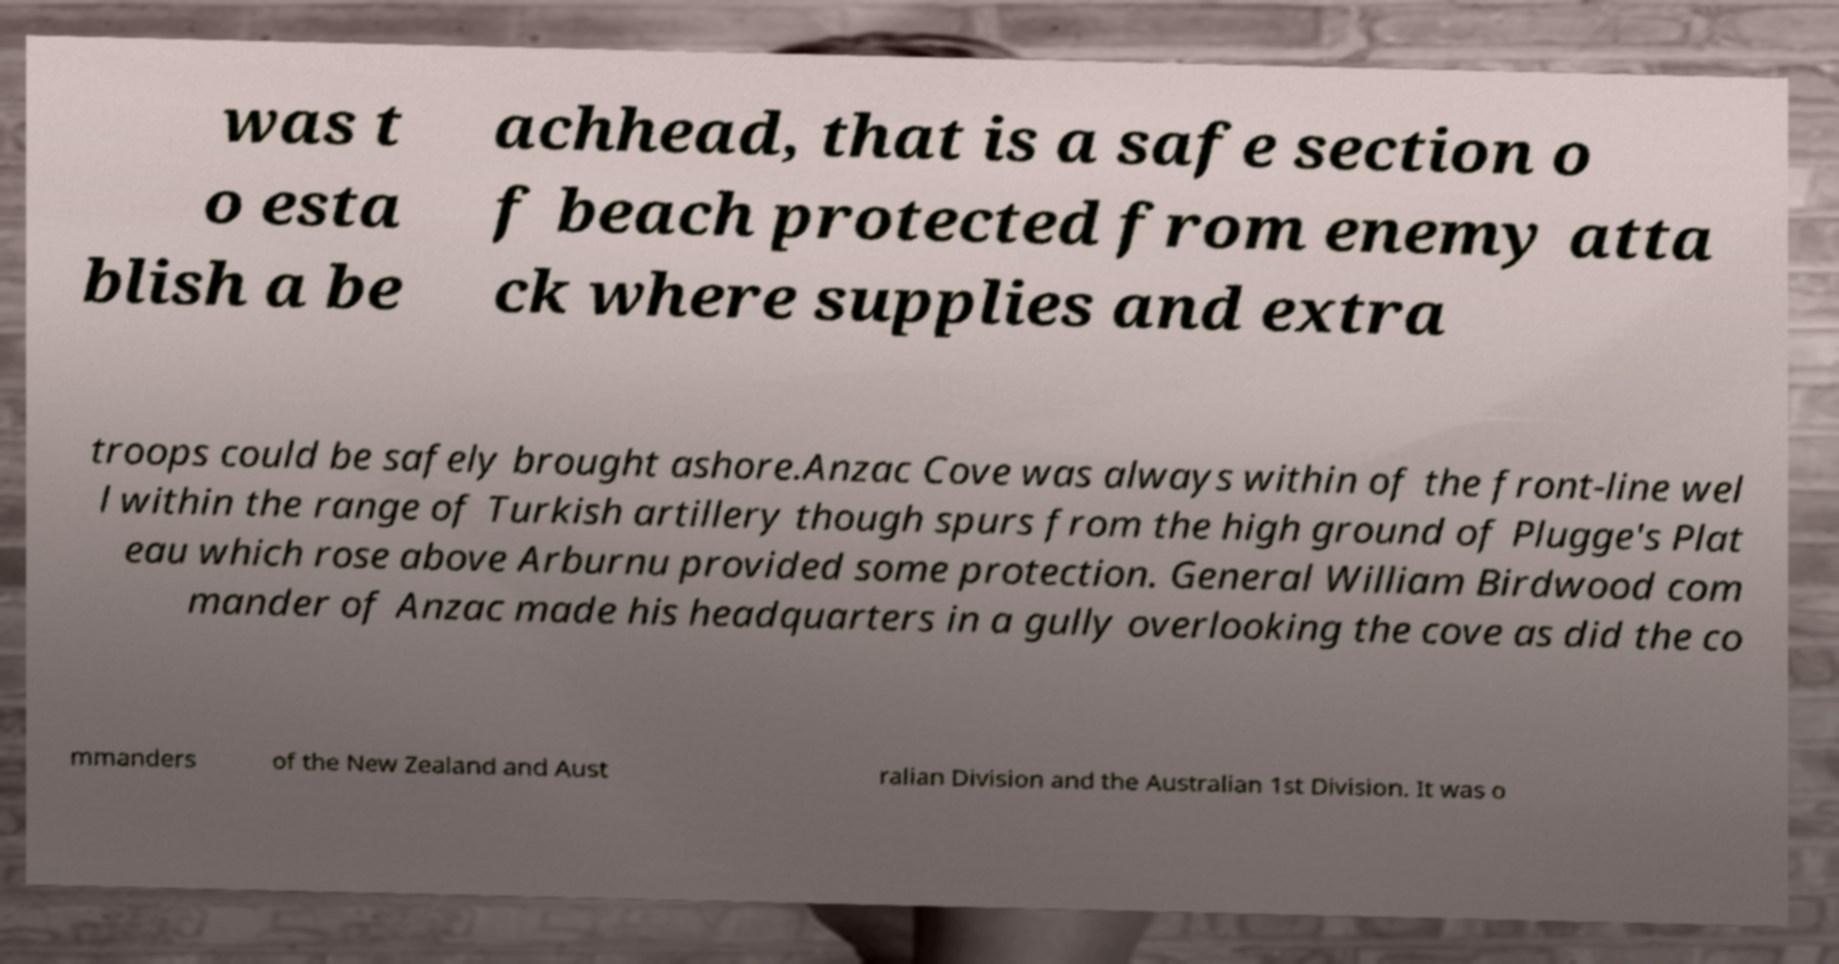Can you read and provide the text displayed in the image?This photo seems to have some interesting text. Can you extract and type it out for me? was t o esta blish a be achhead, that is a safe section o f beach protected from enemy atta ck where supplies and extra troops could be safely brought ashore.Anzac Cove was always within of the front-line wel l within the range of Turkish artillery though spurs from the high ground of Plugge's Plat eau which rose above Arburnu provided some protection. General William Birdwood com mander of Anzac made his headquarters in a gully overlooking the cove as did the co mmanders of the New Zealand and Aust ralian Division and the Australian 1st Division. It was o 